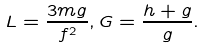<formula> <loc_0><loc_0><loc_500><loc_500>L = \frac { 3 m g } { f ^ { 2 } } , G = \frac { h + g } { g } .</formula> 